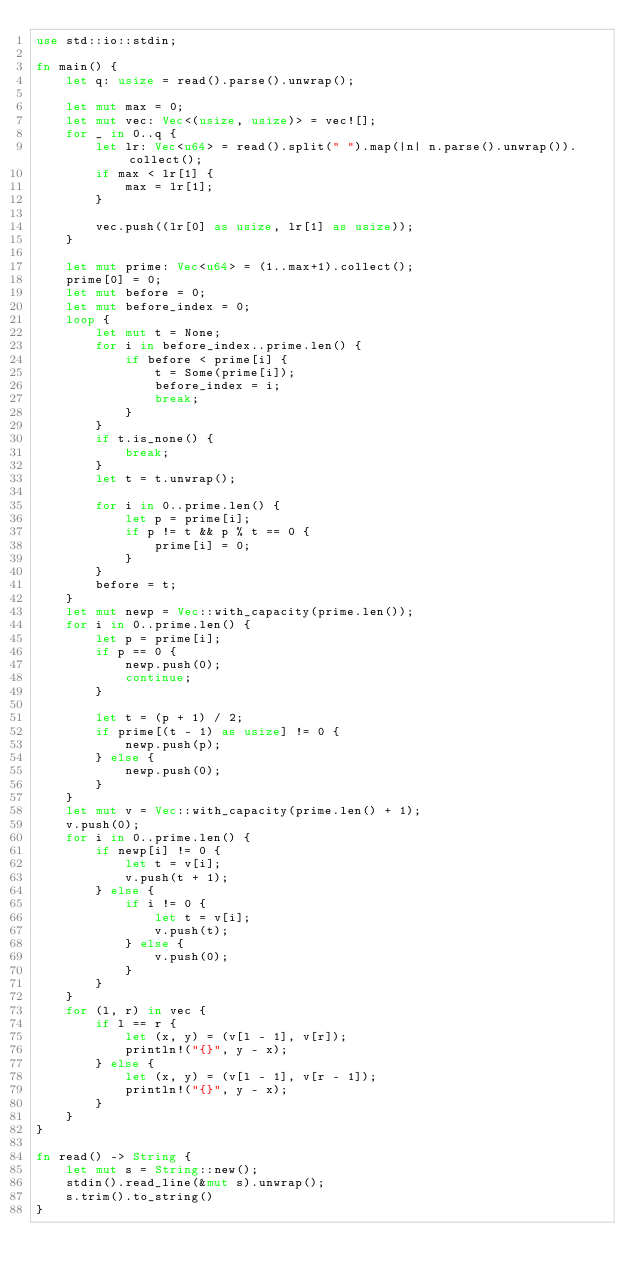Convert code to text. <code><loc_0><loc_0><loc_500><loc_500><_Rust_>use std::io::stdin;

fn main() {
    let q: usize = read().parse().unwrap();
    
    let mut max = 0;
    let mut vec: Vec<(usize, usize)> = vec![];
    for _ in 0..q {
        let lr: Vec<u64> = read().split(" ").map(|n| n.parse().unwrap()).collect();
        if max < lr[1] {
            max = lr[1];
        }
        
        vec.push((lr[0] as usize, lr[1] as usize));
    }
    
    let mut prime: Vec<u64> = (1..max+1).collect();
    prime[0] = 0;
    let mut before = 0;
    let mut before_index = 0;
    loop {
        let mut t = None;
        for i in before_index..prime.len() {
            if before < prime[i] {
                t = Some(prime[i]);
                before_index = i;
                break;
            }
        }
        if t.is_none() {
            break;
        }
        let t = t.unwrap();
        
        for i in 0..prime.len() {
            let p = prime[i];
            if p != t && p % t == 0 {
                prime[i] = 0;
            }
        }
        before = t;
    }
    let mut newp = Vec::with_capacity(prime.len());
    for i in 0..prime.len() {
        let p = prime[i];
        if p == 0 {
            newp.push(0);
            continue;
        }
        
        let t = (p + 1) / 2;
        if prime[(t - 1) as usize] != 0 {
            newp.push(p);
        } else {
            newp.push(0);
        }
    }
    let mut v = Vec::with_capacity(prime.len() + 1);
    v.push(0);
    for i in 0..prime.len() {
        if newp[i] != 0 {
            let t = v[i];
            v.push(t + 1);
        } else {
            if i != 0 {
                let t = v[i];
                v.push(t);
            } else {
                v.push(0);
            }
        }
    }
    for (l, r) in vec {
        if l == r {
            let (x, y) = (v[l - 1], v[r]);
            println!("{}", y - x);
        } else {
            let (x, y) = (v[l - 1], v[r - 1]);
            println!("{}", y - x);
        }
    }
}

fn read() -> String {
    let mut s = String::new();
    stdin().read_line(&mut s).unwrap();
    s.trim().to_string()
}</code> 